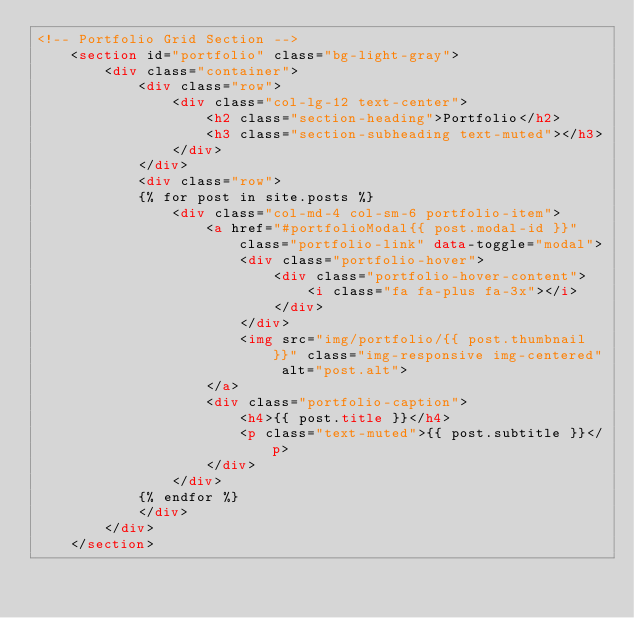<code> <loc_0><loc_0><loc_500><loc_500><_HTML_><!-- Portfolio Grid Section -->
    <section id="portfolio" class="bg-light-gray">
        <div class="container">
            <div class="row">
                <div class="col-lg-12 text-center">
                    <h2 class="section-heading">Portfolio</h2>
                    <h3 class="section-subheading text-muted"></h3>
                </div>
            </div>
            <div class="row">
            {% for post in site.posts %}
                <div class="col-md-4 col-sm-6 portfolio-item">
                    <a href="#portfolioModal{{ post.modal-id }}" class="portfolio-link" data-toggle="modal">
                        <div class="portfolio-hover">
                            <div class="portfolio-hover-content">
                                <i class="fa fa-plus fa-3x"></i>
                            </div>
                        </div>
                        <img src="img/portfolio/{{ post.thumbnail }}" class="img-responsive img-centered" alt="post.alt">
                    </a>
                    <div class="portfolio-caption">
                        <h4>{{ post.title }}</h4>
                        <p class="text-muted">{{ post.subtitle }}</p>
                    </div>
                </div>
            {% endfor %}
            </div>
        </div>
    </section>
</code> 